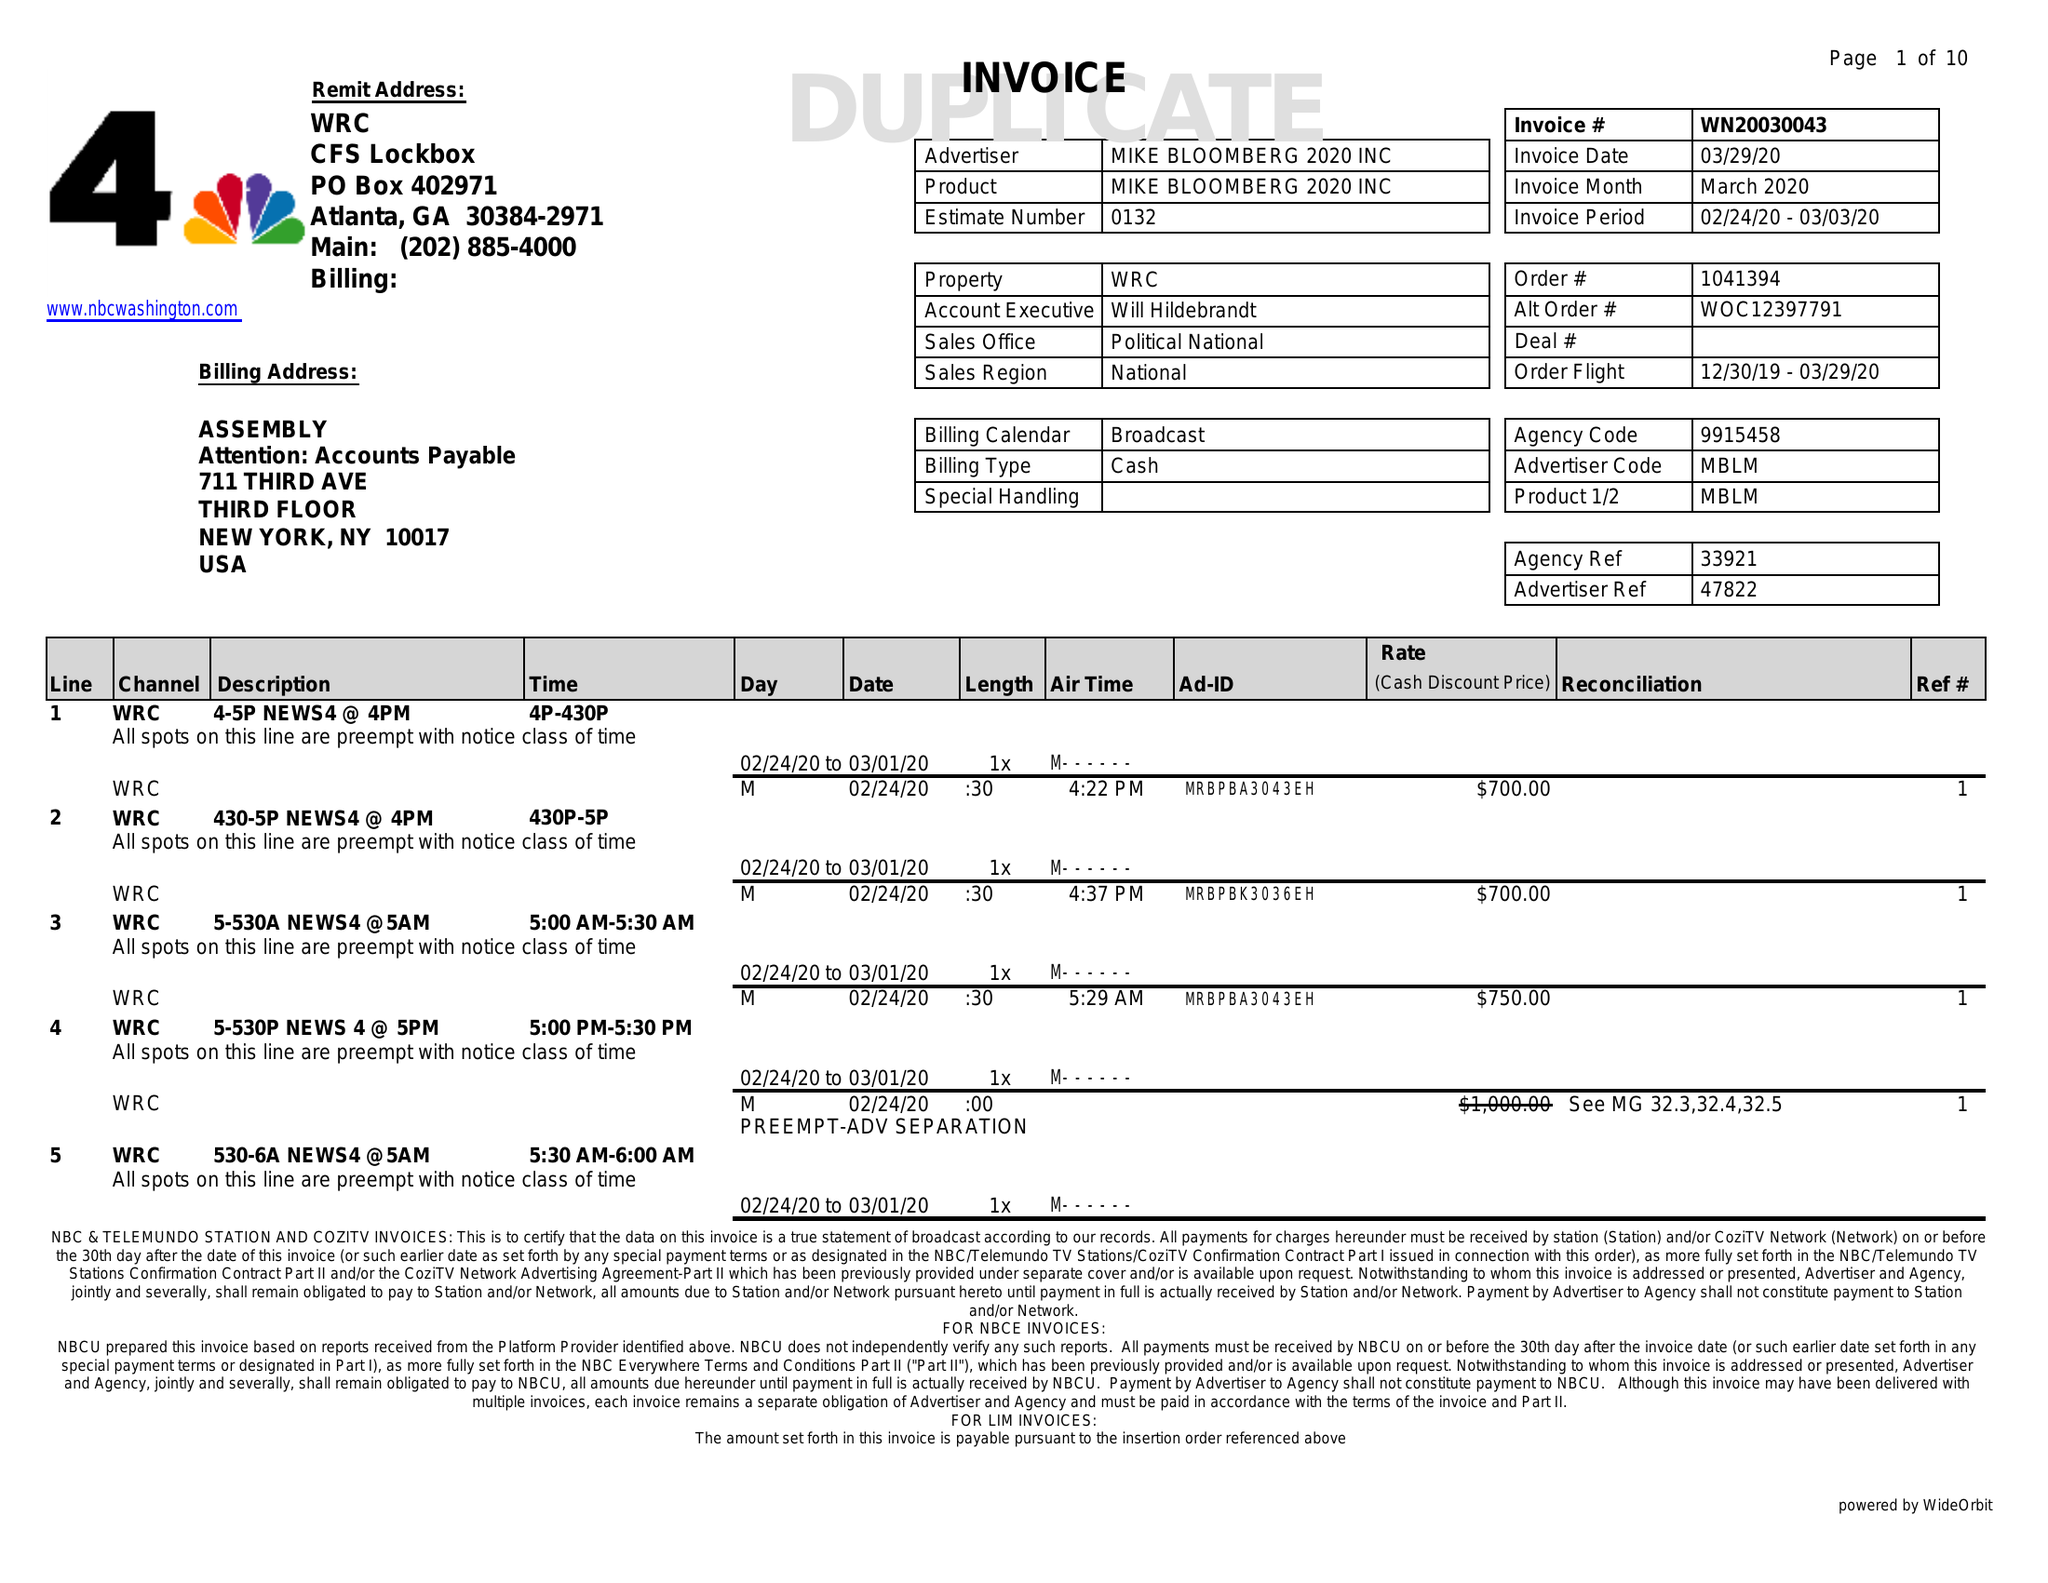What is the value for the gross_amount?
Answer the question using a single word or phrase. 50300.00 